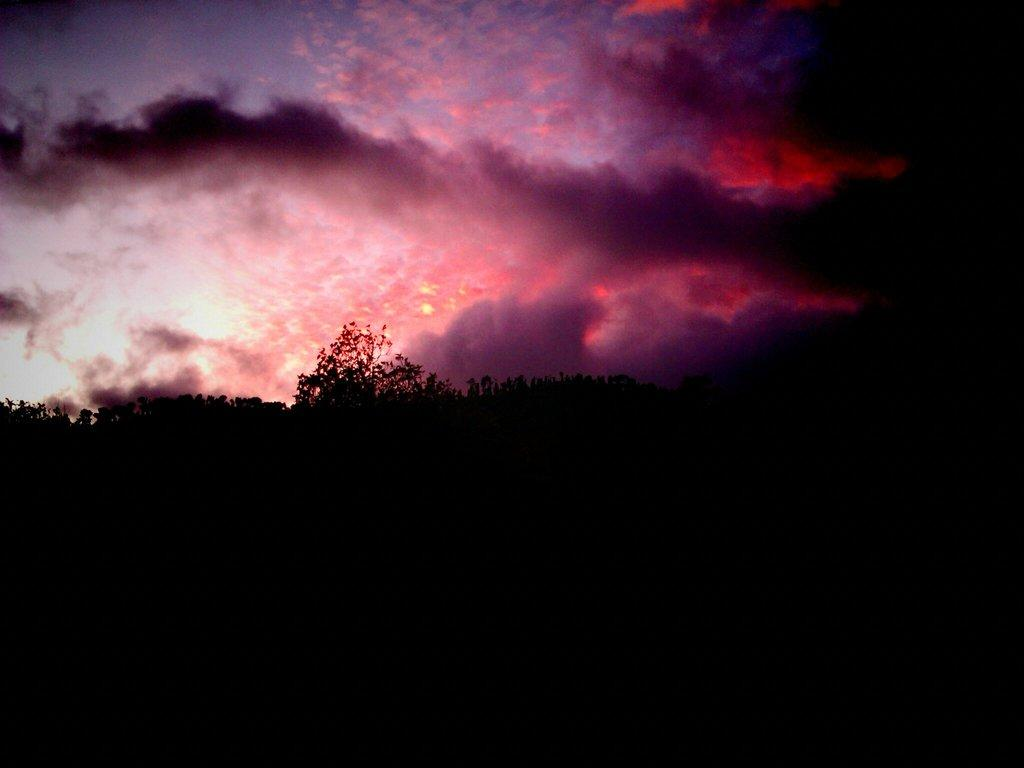What type of living organisms can be seen in the image? Plants can be seen in the image. What is visible in the background of the image? The sky is visible in the background of the image. How would you describe the sky in the image? The sky appears to be cloudy in the image. What type of cast can be seen on the plant in the image? There is no cast present on any plant in the image. Is there a band playing music in the background of the image? There is no band or music present in the image; it only features plants and a cloudy sky. 